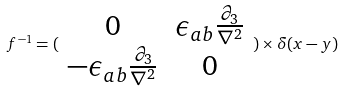<formula> <loc_0><loc_0><loc_500><loc_500>f ^ { - 1 } = ( \begin{array} { c c } 0 & \epsilon _ { a b } \frac { \partial _ { 3 } } { \nabla ^ { 2 } } \\ - \epsilon _ { a b } \frac { \partial _ { 3 } } { \nabla ^ { 2 } } & 0 \end{array} ) \times \delta ( x - y )</formula> 